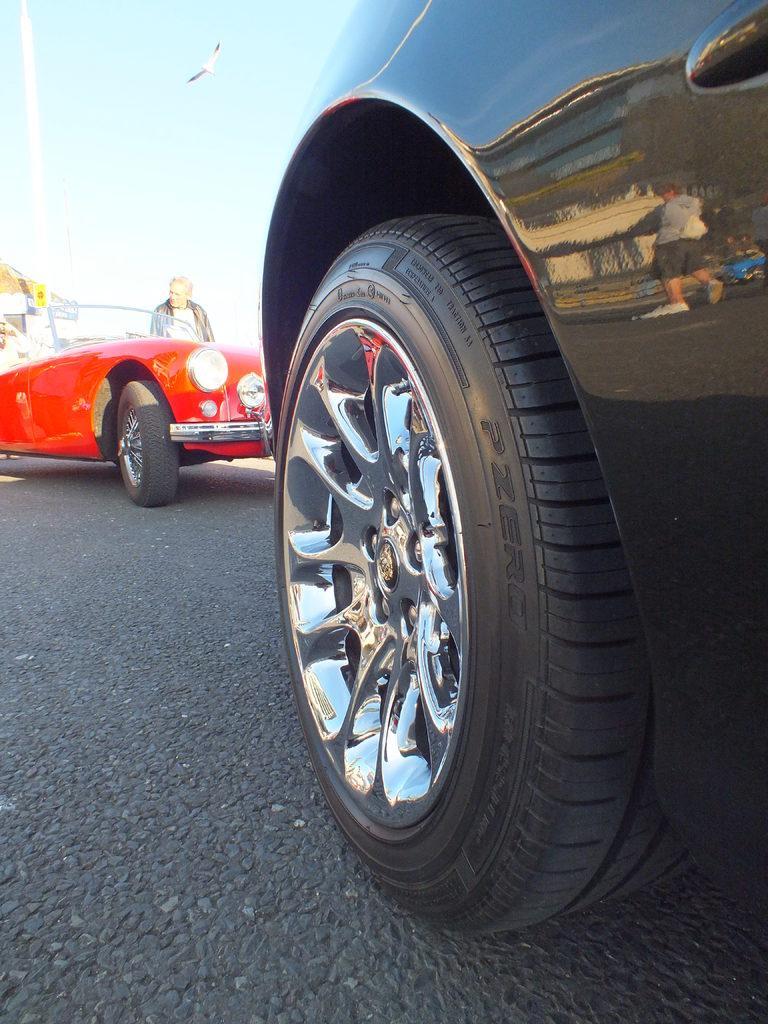In one or two sentences, can you explain what this image depicts? In the foreground of the image we can see the black color car tire. On the top of the image we can see the sky and a bird. One red color car and near to that one person is standing. 